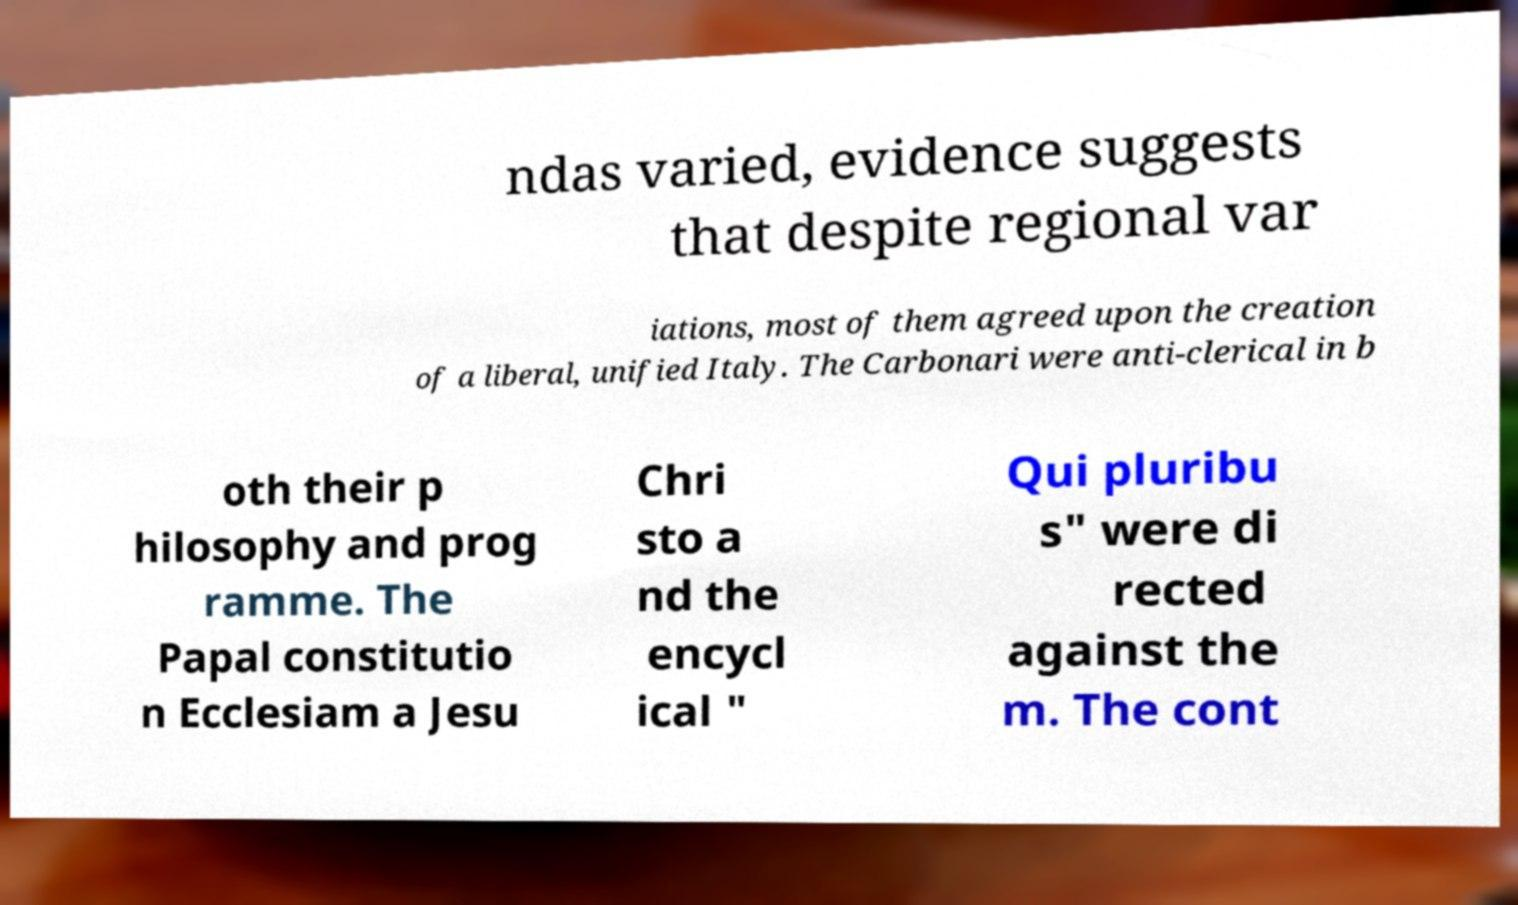Please identify and transcribe the text found in this image. ndas varied, evidence suggests that despite regional var iations, most of them agreed upon the creation of a liberal, unified Italy. The Carbonari were anti-clerical in b oth their p hilosophy and prog ramme. The Papal constitutio n Ecclesiam a Jesu Chri sto a nd the encycl ical " Qui pluribu s" were di rected against the m. The cont 